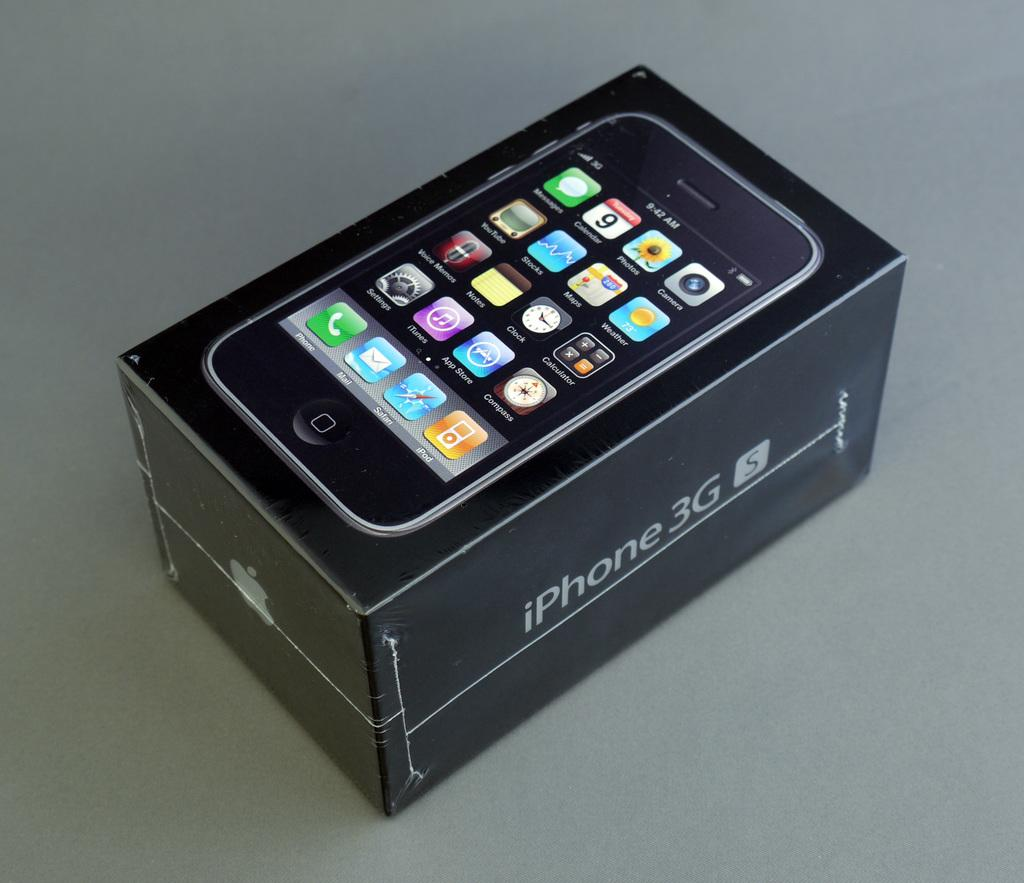<image>
Create a compact narrative representing the image presented. an iPhone box has many icons on the front 